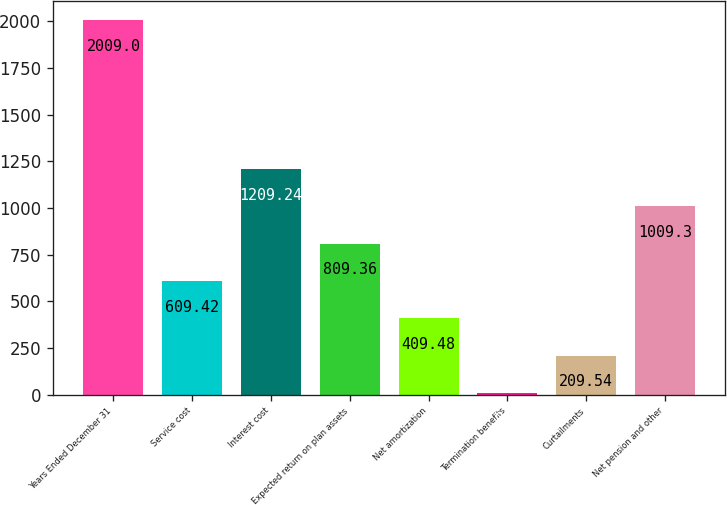Convert chart. <chart><loc_0><loc_0><loc_500><loc_500><bar_chart><fcel>Years Ended December 31<fcel>Service cost<fcel>Interest cost<fcel>Expected return on plan assets<fcel>Net amortization<fcel>Termination benefits<fcel>Curtailments<fcel>Net pension and other<nl><fcel>2009<fcel>609.42<fcel>1209.24<fcel>809.36<fcel>409.48<fcel>9.6<fcel>209.54<fcel>1009.3<nl></chart> 